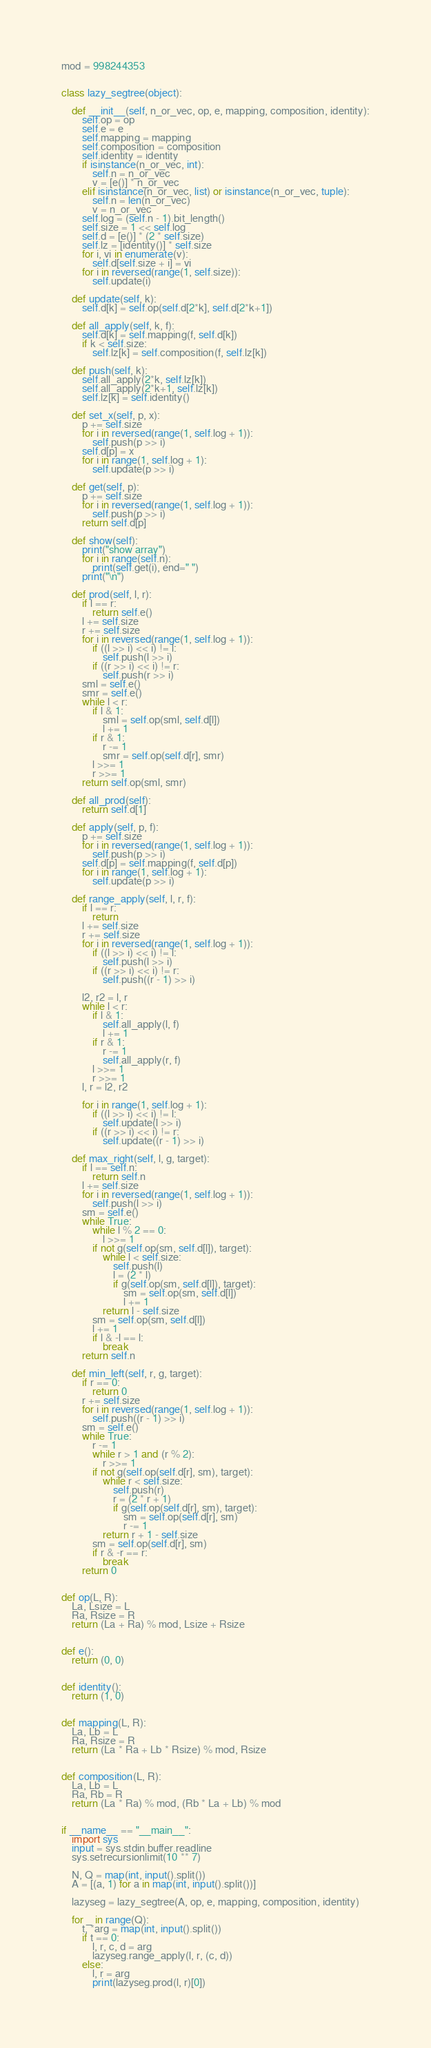<code> <loc_0><loc_0><loc_500><loc_500><_Python_>mod = 998244353


class lazy_segtree(object):

    def __init__(self, n_or_vec, op, e, mapping, composition, identity):
        self.op = op
        self.e = e
        self.mapping = mapping
        self.composition = composition
        self.identity = identity
        if isinstance(n_or_vec, int):
            self.n = n_or_vec
            v = [e()] * n_or_vec
        elif isinstance(n_or_vec, list) or isinstance(n_or_vec, tuple):
            self.n = len(n_or_vec)
            v = n_or_vec
        self.log = (self.n - 1).bit_length()
        self.size = 1 << self.log
        self.d = [e()] * (2 * self.size)
        self.lz = [identity()] * self.size
        for i, vi in enumerate(v):
            self.d[self.size + i] = vi
        for i in reversed(range(1, self.size)):
            self.update(i)

    def update(self, k):
        self.d[k] = self.op(self.d[2*k], self.d[2*k+1])

    def all_apply(self, k, f):
        self.d[k] = self.mapping(f, self.d[k])
        if k < self.size:
            self.lz[k] = self.composition(f, self.lz[k])

    def push(self, k):
        self.all_apply(2*k, self.lz[k])
        self.all_apply(2*k+1, self.lz[k])
        self.lz[k] = self.identity()

    def set_x(self, p, x):
        p += self.size
        for i in reversed(range(1, self.log + 1)):
            self.push(p >> i)
        self.d[p] = x
        for i in range(1, self.log + 1):
            self.update(p >> i)

    def get(self, p):
        p += self.size
        for i in reversed(range(1, self.log + 1)):
            self.push(p >> i)
        return self.d[p]

    def show(self):
        print("show array")
        for i in range(self.n):
            print(self.get(i), end=" ")
        print("\n")

    def prod(self, l, r):
        if l == r:
            return self.e()
        l += self.size
        r += self.size
        for i in reversed(range(1, self.log + 1)):
            if ((l >> i) << i) != l:
                self.push(l >> i)
            if ((r >> i) << i) != r:
                self.push(r >> i)
        sml = self.e()
        smr = self.e()
        while l < r:
            if l & 1:
                sml = self.op(sml, self.d[l])
                l += 1
            if r & 1:
                r -= 1
                smr = self.op(self.d[r], smr)
            l >>= 1
            r >>= 1
        return self.op(sml, smr)

    def all_prod(self):
        return self.d[1]

    def apply(self, p, f):
        p += self.size
        for i in reversed(range(1, self.log + 1)):
            self.push(p >> i)
        self.d[p] = self.mapping(f, self.d[p])
        for i in range(1, self.log + 1):
            self.update(p >> i)

    def range_apply(self, l, r, f):
        if l == r:
            return
        l += self.size
        r += self.size
        for i in reversed(range(1, self.log + 1)):
            if ((l >> i) << i) != l:
                self.push(l >> i)
            if ((r >> i) << i) != r:
                self.push((r - 1) >> i)

        l2, r2 = l, r
        while l < r:
            if l & 1:
                self.all_apply(l, f)
                l += 1
            if r & 1:
                r -= 1
                self.all_apply(r, f)
            l >>= 1
            r >>= 1
        l, r = l2, r2

        for i in range(1, self.log + 1):
            if ((l >> i) << i) != l:
                self.update(l >> i)
            if ((r >> i) << i) != r:
                self.update((r - 1) >> i)

    def max_right(self, l, g, target):
        if l == self.n:
            return self.n
        l += self.size
        for i in reversed(range(1, self.log + 1)):
            self.push(l >> i)
        sm = self.e()
        while True:
            while l % 2 == 0:
                l >>= 1
            if not g(self.op(sm, self.d[l]), target):
                while l < self.size:
                    self.push(l)
                    l = (2 * l)
                    if g(self.op(sm, self.d[l]), target):
                        sm = self.op(sm, self.d[l])
                        l += 1
                return l - self.size
            sm = self.op(sm, self.d[l])
            l += 1
            if l & -l == l:
                break
        return self.n

    def min_left(self, r, g, target):
        if r == 0:
            return 0
        r += self.size
        for i in reversed(range(1, self.log + 1)):
            self.push((r - 1) >> i)
        sm = self.e()
        while True:
            r -= 1
            while r > 1 and (r % 2):
                r >>= 1
            if not g(self.op(self.d[r], sm), target):
                while r < self.size:
                    self.push(r)
                    r = (2 * r + 1)
                    if g(self.op(self.d[r], sm), target):
                        sm = self.op(self.d[r], sm)
                        r -= 1
                return r + 1 - self.size
            sm = self.op(self.d[r], sm)
            if r & -r == r:
                break
        return 0


def op(L, R):
    La, Lsize = L
    Ra, Rsize = R
    return (La + Ra) % mod, Lsize + Rsize


def e():
    return (0, 0)


def identity():
    return (1, 0)


def mapping(L, R):
    La, Lb = L
    Ra, Rsize = R
    return (La * Ra + Lb * Rsize) % mod, Rsize


def composition(L, R):
    La, Lb = L
    Ra, Rb = R
    return (La * Ra) % mod, (Rb * La + Lb) % mod


if __name__ == "__main__":
    import sys
    input = sys.stdin.buffer.readline
    sys.setrecursionlimit(10 ** 7)

    N, Q = map(int, input().split())
    A = [(a, 1) for a in map(int, input().split())]

    lazyseg = lazy_segtree(A, op, e, mapping, composition, identity)

    for _ in range(Q):
        t, *arg = map(int, input().split())
        if t == 0:
            l, r, c, d = arg
            lazyseg.range_apply(l, r, (c, d))
        else:
            l, r = arg
            print(lazyseg.prod(l, r)[0])</code> 